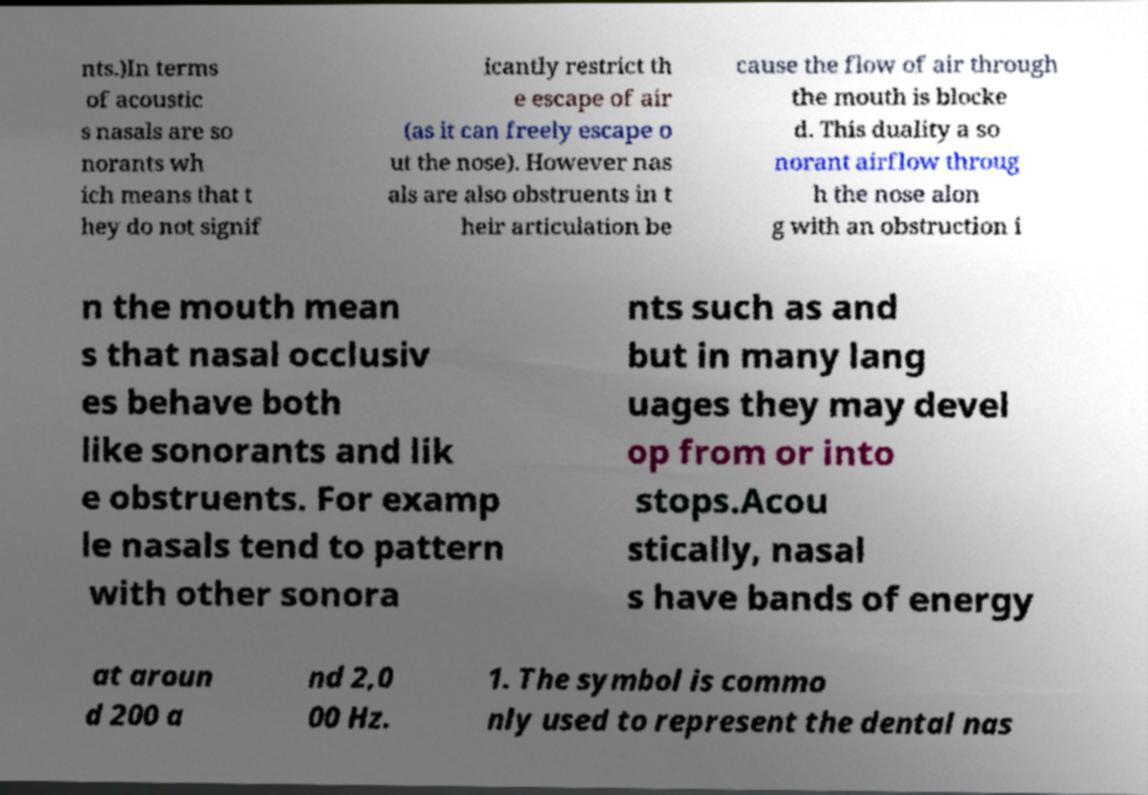Can you read and provide the text displayed in the image?This photo seems to have some interesting text. Can you extract and type it out for me? nts.)In terms of acoustic s nasals are so norants wh ich means that t hey do not signif icantly restrict th e escape of air (as it can freely escape o ut the nose). However nas als are also obstruents in t heir articulation be cause the flow of air through the mouth is blocke d. This duality a so norant airflow throug h the nose alon g with an obstruction i n the mouth mean s that nasal occlusiv es behave both like sonorants and lik e obstruents. For examp le nasals tend to pattern with other sonora nts such as and but in many lang uages they may devel op from or into stops.Acou stically, nasal s have bands of energy at aroun d 200 a nd 2,0 00 Hz. 1. The symbol is commo nly used to represent the dental nas 